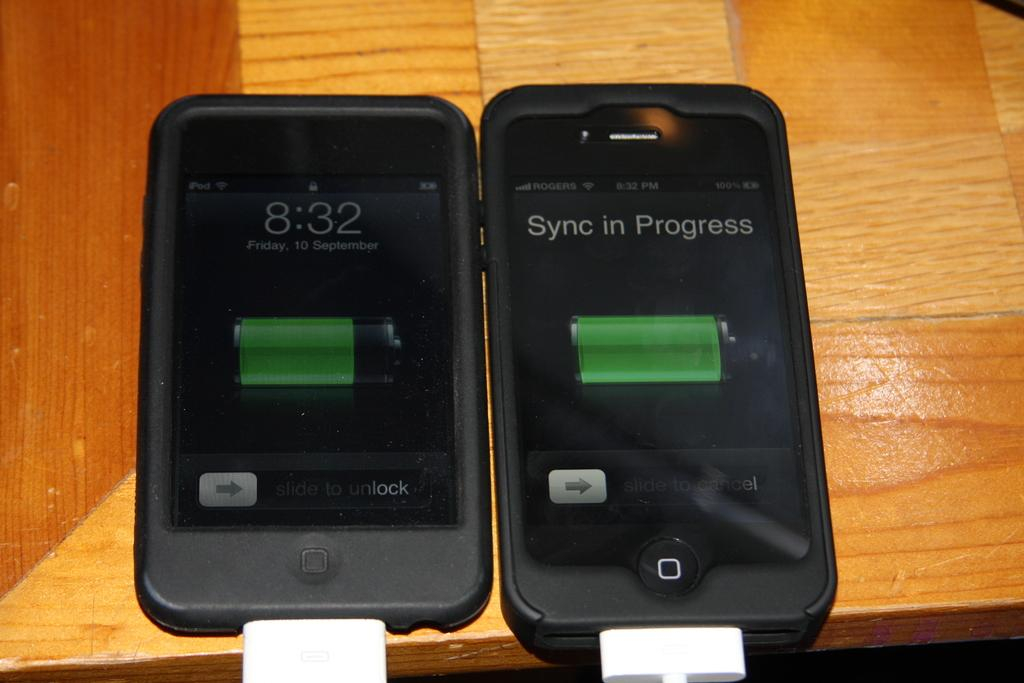<image>
Present a compact description of the photo's key features. Two black iphones are lying next to each other while one has a sync in progress. 